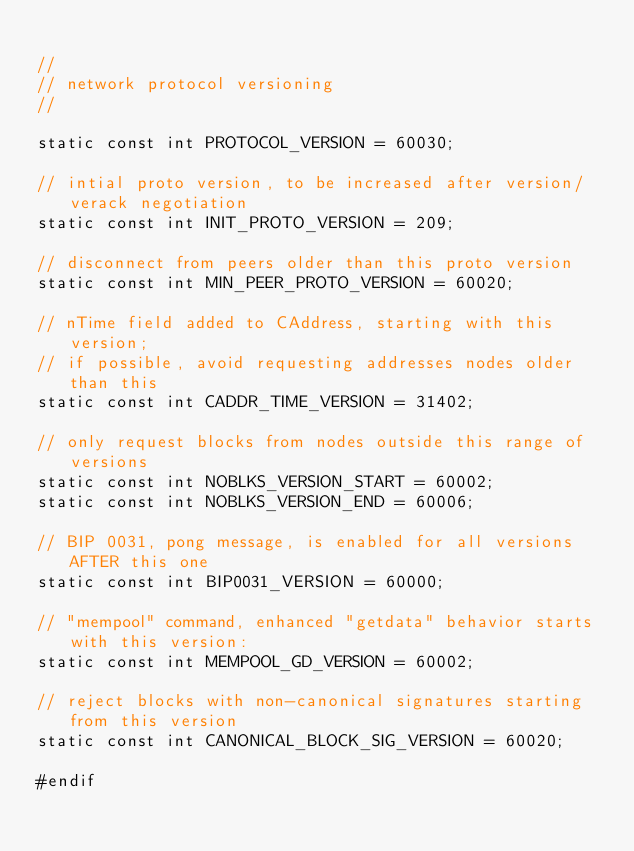<code> <loc_0><loc_0><loc_500><loc_500><_C_>
//
// network protocol versioning
//

static const int PROTOCOL_VERSION = 60030;

// intial proto version, to be increased after version/verack negotiation
static const int INIT_PROTO_VERSION = 209;

// disconnect from peers older than this proto version
static const int MIN_PEER_PROTO_VERSION = 60020;

// nTime field added to CAddress, starting with this version;
// if possible, avoid requesting addresses nodes older than this
static const int CADDR_TIME_VERSION = 31402;

// only request blocks from nodes outside this range of versions
static const int NOBLKS_VERSION_START = 60002;
static const int NOBLKS_VERSION_END = 60006;

// BIP 0031, pong message, is enabled for all versions AFTER this one
static const int BIP0031_VERSION = 60000;

// "mempool" command, enhanced "getdata" behavior starts with this version:
static const int MEMPOOL_GD_VERSION = 60002;

// reject blocks with non-canonical signatures starting from this version
static const int CANONICAL_BLOCK_SIG_VERSION = 60020;

#endif
</code> 